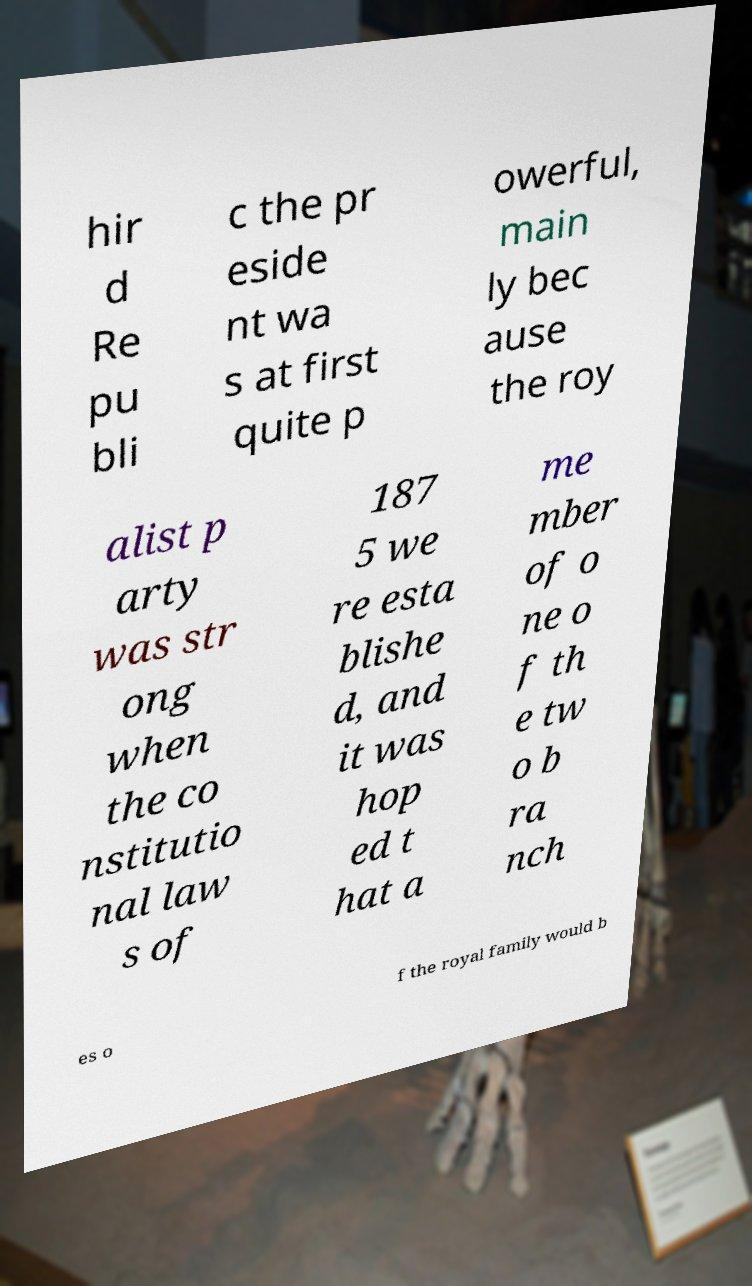I need the written content from this picture converted into text. Can you do that? hir d Re pu bli c the pr eside nt wa s at first quite p owerful, main ly bec ause the roy alist p arty was str ong when the co nstitutio nal law s of 187 5 we re esta blishe d, and it was hop ed t hat a me mber of o ne o f th e tw o b ra nch es o f the royal family would b 